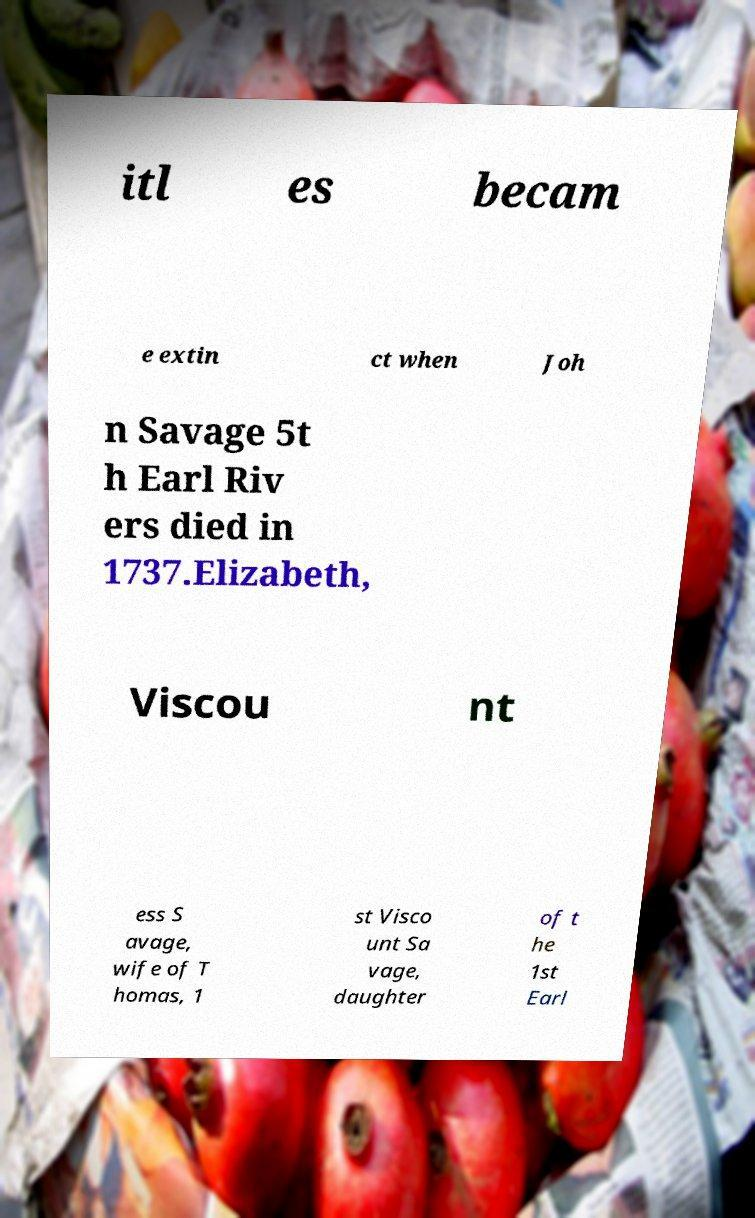Can you read and provide the text displayed in the image?This photo seems to have some interesting text. Can you extract and type it out for me? itl es becam e extin ct when Joh n Savage 5t h Earl Riv ers died in 1737.Elizabeth, Viscou nt ess S avage, wife of T homas, 1 st Visco unt Sa vage, daughter of t he 1st Earl 